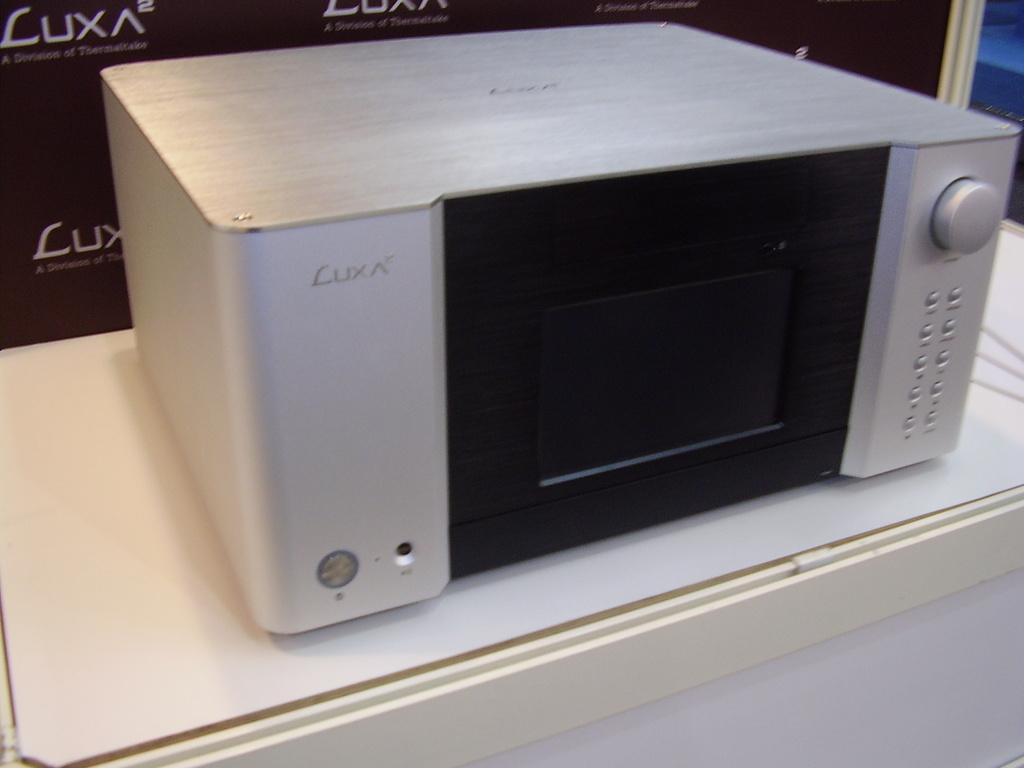What brand of microwave is this?
Your response must be concise. Luxa. 